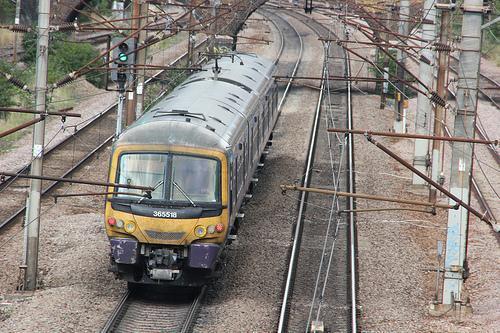How many trains are on the track to the right?
Give a very brief answer. 0. 